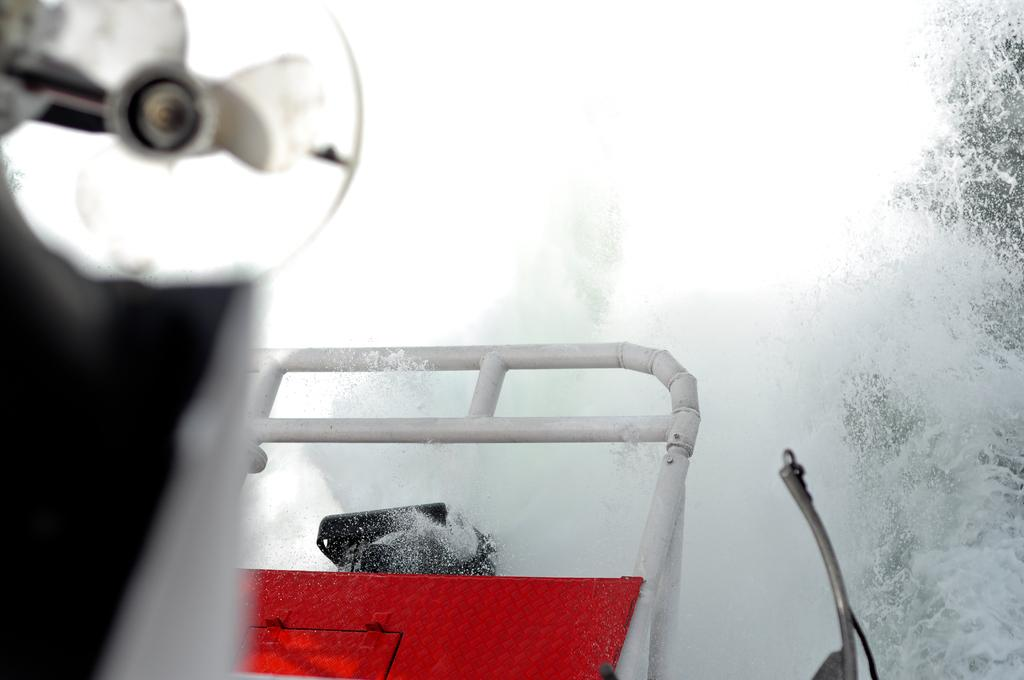What type of appliance is present in the image? There is a fan in the image. Can you describe the colors of the object in the image? The object in the image has black, white, and red colors. What is the primary element visible in the image? There is water visible in the image. What type of wax is used to create the fan in the image? There is no mention of wax being used to create the fan in the image. What disease is being treated by the object in the image? There is no indication of a disease or medical treatment in the image. 